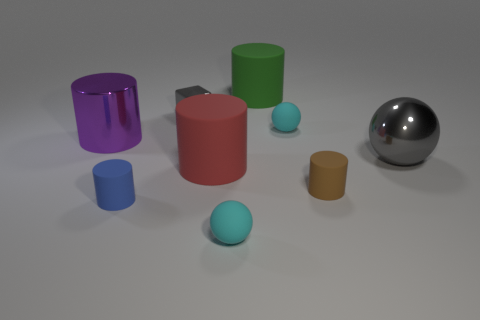Subtract all tiny balls. How many balls are left? 1 Add 1 big purple matte objects. How many objects exist? 10 Subtract 1 blocks. How many blocks are left? 0 Subtract all gray balls. How many balls are left? 2 Subtract all spheres. How many objects are left? 6 Add 1 tiny gray shiny blocks. How many tiny gray shiny blocks exist? 2 Subtract 0 gray cylinders. How many objects are left? 9 Subtract all yellow balls. Subtract all purple cylinders. How many balls are left? 3 Subtract all red spheres. How many cyan blocks are left? 0 Subtract all brown shiny cubes. Subtract all large green things. How many objects are left? 8 